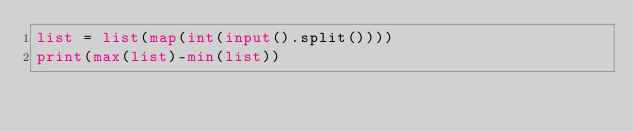<code> <loc_0><loc_0><loc_500><loc_500><_Python_>list = list(map(int(input().split())))
print(max(list)-min(list))</code> 